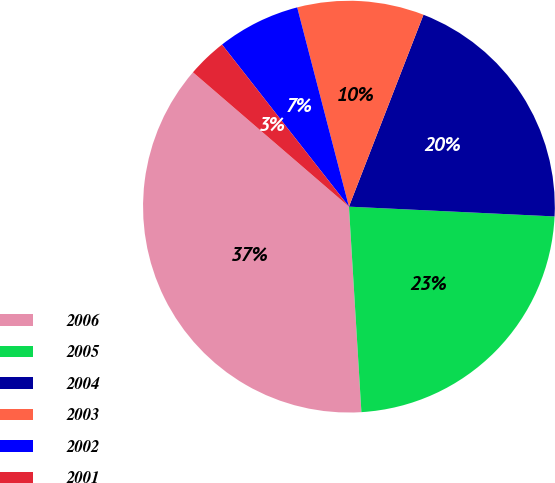<chart> <loc_0><loc_0><loc_500><loc_500><pie_chart><fcel>2006<fcel>2005<fcel>2004<fcel>2003<fcel>2002<fcel>2001<nl><fcel>37.28%<fcel>23.28%<fcel>19.86%<fcel>9.94%<fcel>6.53%<fcel>3.11%<nl></chart> 